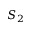<formula> <loc_0><loc_0><loc_500><loc_500>S _ { 2 }</formula> 